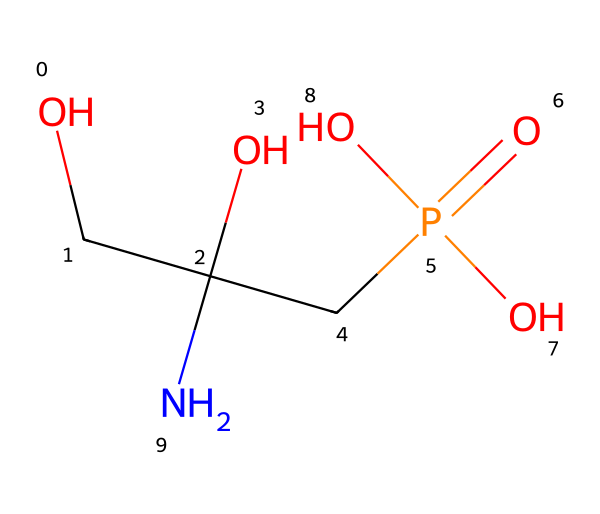What is the total number of carbon atoms in glyphosate? The SMILES notation shows 'OCC(O)' indicating there are two carbon atoms from 'C(C)', plus one more from 'C' in 'CP(=O)', leading to a total of three carbon atoms.
Answer: three How many oxygen atoms are present in glyphosate? The SMILES notation contains 'O' in several sections: there are three from 'O', and one from 'P(=O)', resulting in a total of four oxygen atoms.
Answer: four What is the main functional group present in glyphosate? The presence of 'P(=O)(O)O' indicates a phosphorus atom bound to oxygen atoms, characteristic of phosphate groups.
Answer: phosphate How many hydrogen atoms are there in glyphosate? Analyzing the structure, each carbon and nitrogen atom typically forms additional bonds with hydrogen. Counting up, there are seven hydrogen atoms connected in total.
Answer: seven What type of compound is glyphosate classified as based on its phosphorus component? Glyphosate contains a phosphorus atom which classifies it as a phosphorus-containing compound. Specifically, due to the presence of the phosphate group, it is categorized further as an organophosphate.
Answer: organophosphate Which part of glyphosate contributes to its herbicidal properties? The nitrogen and the phosphate group (P=O) in the structure are significant for glyphosate's ability to inhibit specific enzymes in plants, leading to herbicidal effects.
Answer: phosphate group 